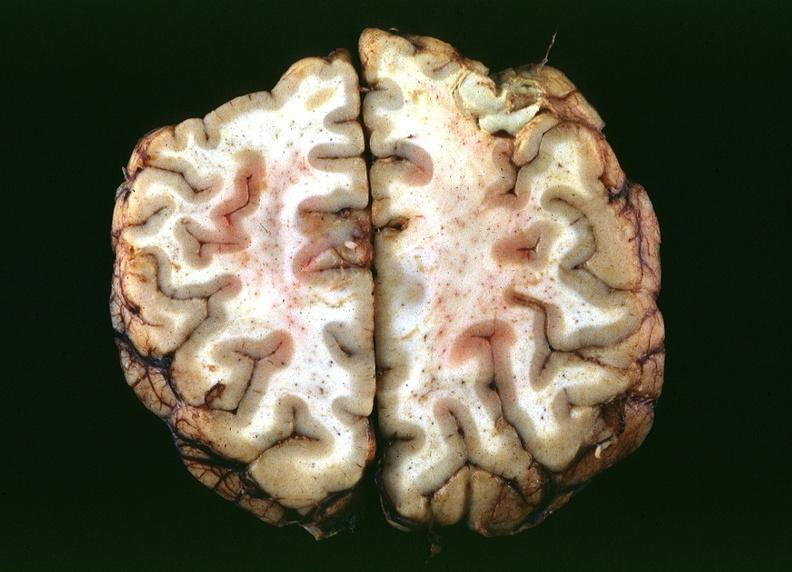s nervous present?
Answer the question using a single word or phrase. Yes 